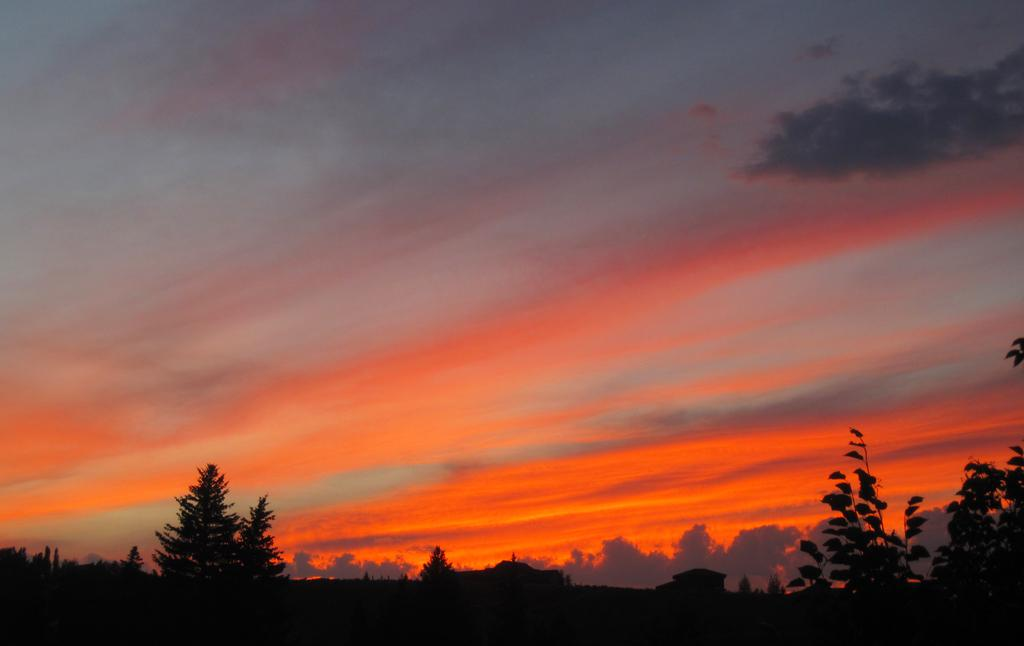What is the setting of the image? The image has an outside view. Where are plants located in the image? There are plants in the bottom left and bottom right of the image. What can be seen in the background of the image? The sky is visible in the background of the image. What type of oven can be seen in the image? There is no oven present in the image. How does the pig contribute to the image? There is no pig present in the image. 